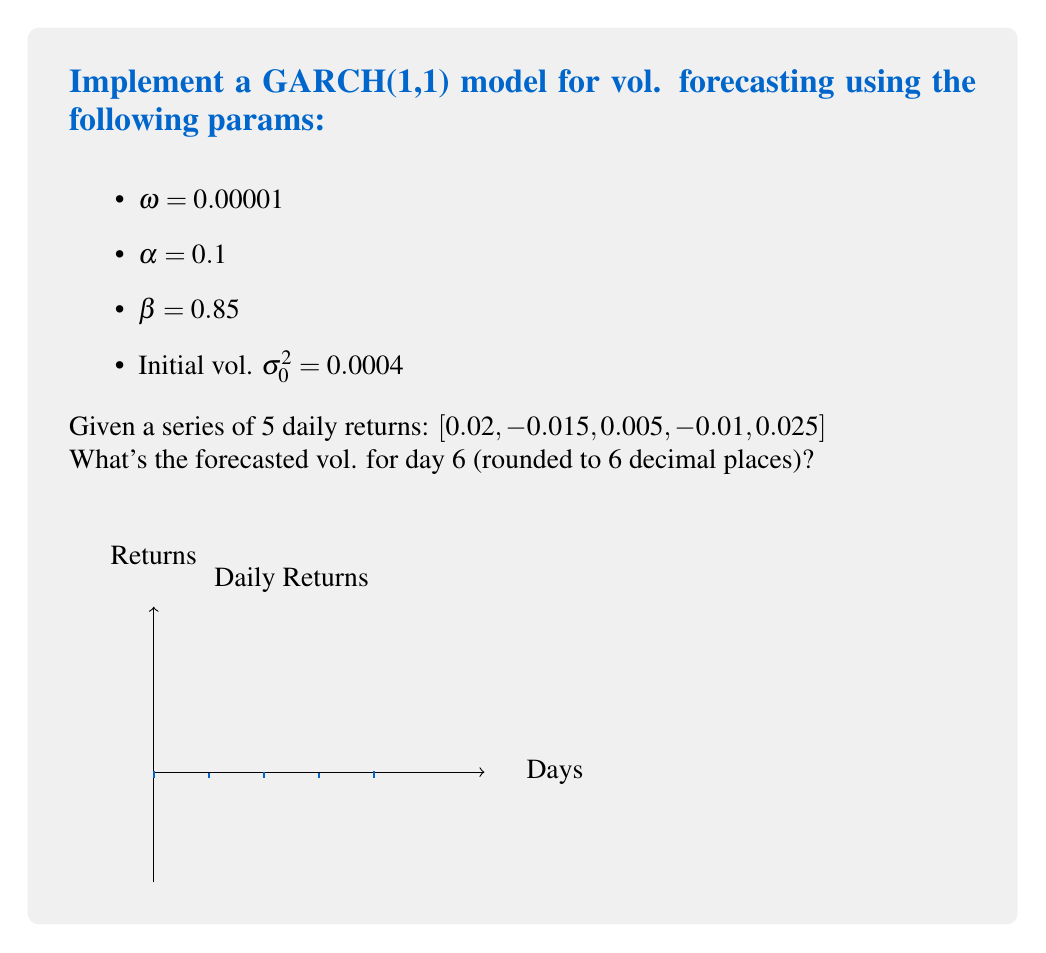Provide a solution to this math problem. To solve this GARCH(1,1) problem, we'll follow these steps:

1) Recall the GARCH(1,1) formula:
   $$\sigma_t^2 = \omega + \alpha r_{t-1}^2 + \beta \sigma_{t-1}^2$$

2) We'll iterate through the given returns to calculate volatility for each day:

   Day 1:
   $$\sigma_1^2 = 0.00001 + 0.1(0.02^2) + 0.85(0.0004) = 0.000381$$

   Day 2:
   $$\sigma_2^2 = 0.00001 + 0.1(-0.015^2) + 0.85(0.000381) = 0.000346825$$

   Day 3:
   $$\sigma_3^2 = 0.00001 + 0.1(0.005^2) + 0.85(0.000346825) = 0.000295301$$

   Day 4:
   $$\sigma_4^2 = 0.00001 + 0.1(-0.01^2) + 0.85(0.000295301) = 0.000261506$$

   Day 5:
   $$\sigma_5^2 = 0.00001 + 0.1(0.025^2) + 0.85(0.000261506) = 0.000285280$$

3) Now we can forecast volatility for day 6:
   $$\sigma_6^2 = 0.00001 + 0.1(0.025^2) + 0.85(0.000285280) = 0.000305988$$

4) Taking the square root to get volatility:
   $$\sigma_6 = \sqrt{0.000305988} = 0.017492$$

5) Rounding to 6 decimal places: 0.017492
Answer: 0.017492 